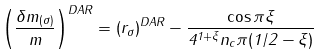<formula> <loc_0><loc_0><loc_500><loc_500>\left ( \frac { \delta m _ { ( \sigma ) } } { m } \right ) ^ { D A R } = ( r _ { \sigma } ) ^ { D A R } - \frac { \cos \pi \xi } { 4 ^ { 1 + \xi } n _ { c } \pi ( 1 / 2 - \xi ) }</formula> 